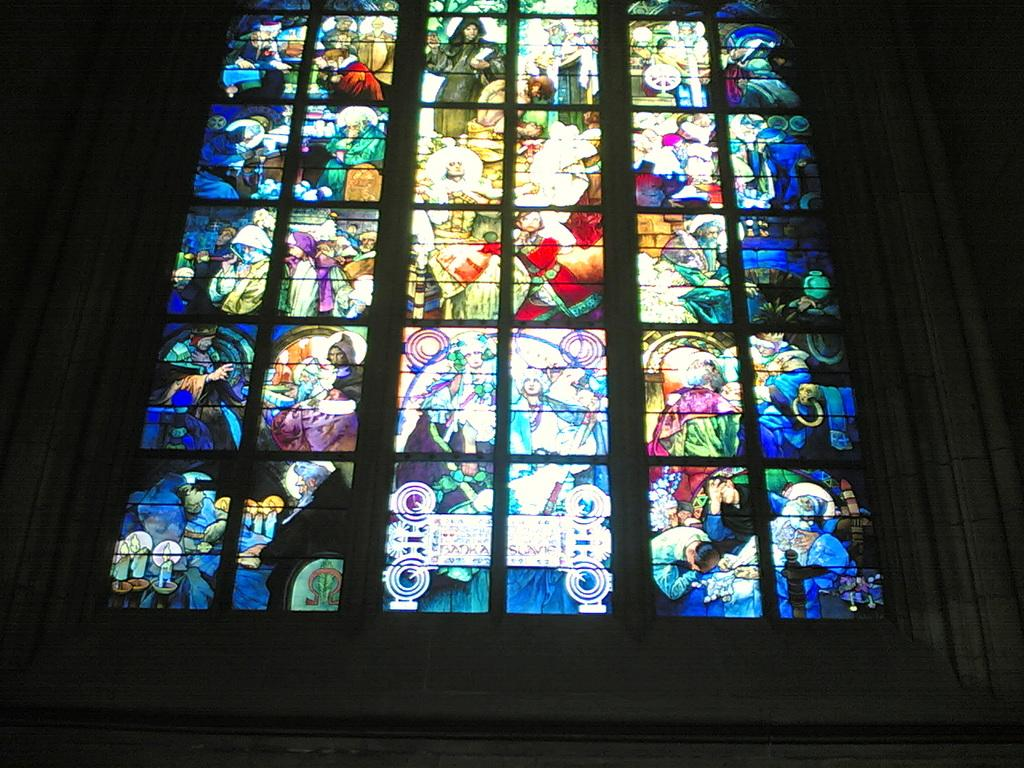What is present on the wall in the image? There is a glass on the wall in the image. What can be seen on the glass? The glass has images of a group of persons on it. What force is being applied to the glass in the image? There is no indication of any force being applied to the glass in the image. What type of voyage is depicted in the image? There is no voyage depicted in the image; it only features a glass with images of a group of persons. 